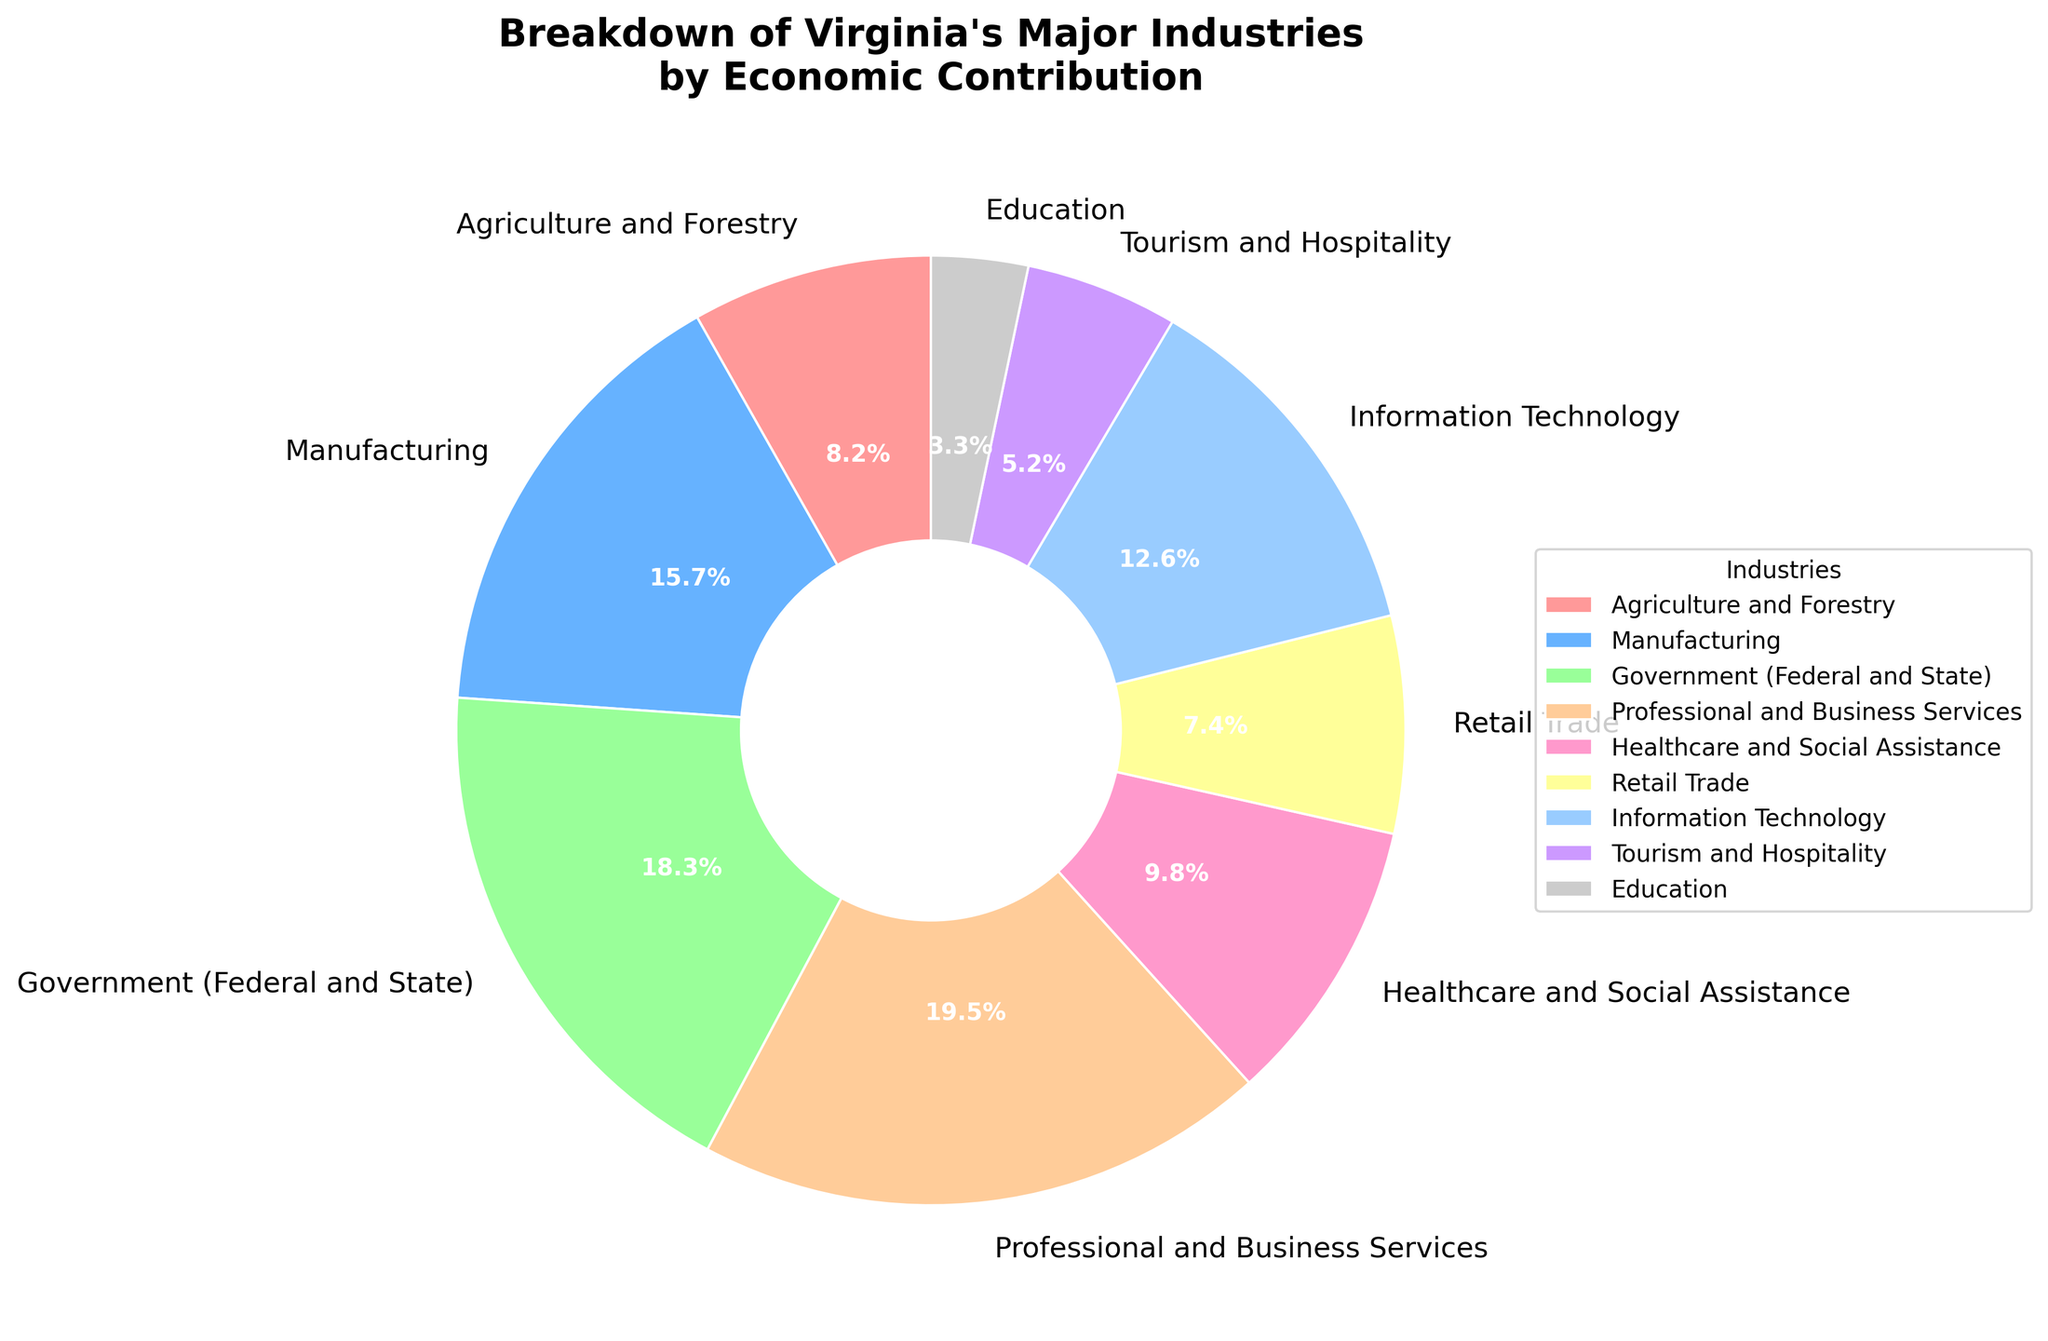What's the economic contribution percentage of the Manufacturing industry? The Manufacturing industry's economic contribution percentage is directly labeled in the pie chart.
Answer: 15.7% Which industry contributes the most to Virginia's economy? The pie chart slices with the largest area and label indicate the industry with the highest contribution.
Answer: Professional and Business Services Which industry has a higher economic contribution, Agriculture and Forestry or Tourism and Hospitality? Compare the labeled percentages of Agriculture and Forestry (8.2%) and Tourism and Hospitality (5.2%).
Answer: Agriculture and Forestry What is the total economic contribution percentage of Government (Federal and State) and Information Technology combined? Sum the percentages of Government (Federal and State) (18.3%) and Information Technology (12.6%): 18.3 + 12.6 = 30.9%.
Answer: 30.9% How much higher is the economic contribution of Professional and Business Services compared to Education? Subtract the percentage value of Education (3.3%) from Professional and Business Services (19.5%): 19.5 - 3.3 = 16.2%.
Answer: 16.2% What percentage of Virginia's economy is contributed by Healthcare and Social Assistance? The Healthcare and Social Assistance contribution is labeled directly on the pie chart.
Answer: 9.8% If you combine the contributions of Agriculture and Forestry, Retail Trade, and Tourism and Hospitality, what would be the total percentage? Add the percentages of Agriculture and Forestry (8.2%), Retail Trade (7.4%), and Tourism and Hospitality (5.2%): 
8.2 + 7.4 + 5.2 = 20.8%.
Answer: 20.8% Which color represents the Healthcare and Social Assistance industry in the pie chart? Identify the color visually associated with the Healthcare and Social Assistance label in the pie chart
Answer: Yellow Is the economic contribution of the Retail Trade industry more or less than 10%? The labeled contribution percentage of Retail Trade (7.4%) is available directly from the pie chart.
Answer: Less What is the difference in economic contribution between Information Technology and Tourism and Hospitality? Subtract the percentage value of Tourism and Hospitality (5.2%) from Information Technology (12.6%): 12.6 - 5.2 = 7.4%.
Answer: 7.4% 